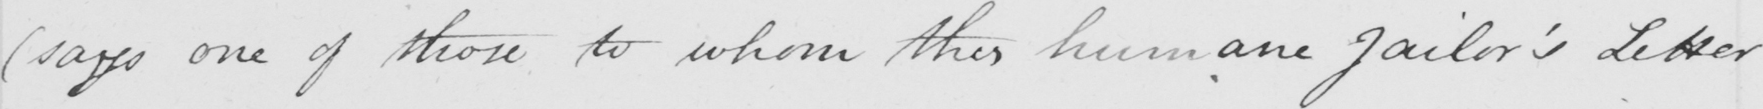Transcribe the text shown in this historical manuscript line. ( says one of those to whom this humane Jailor ' s Letter 